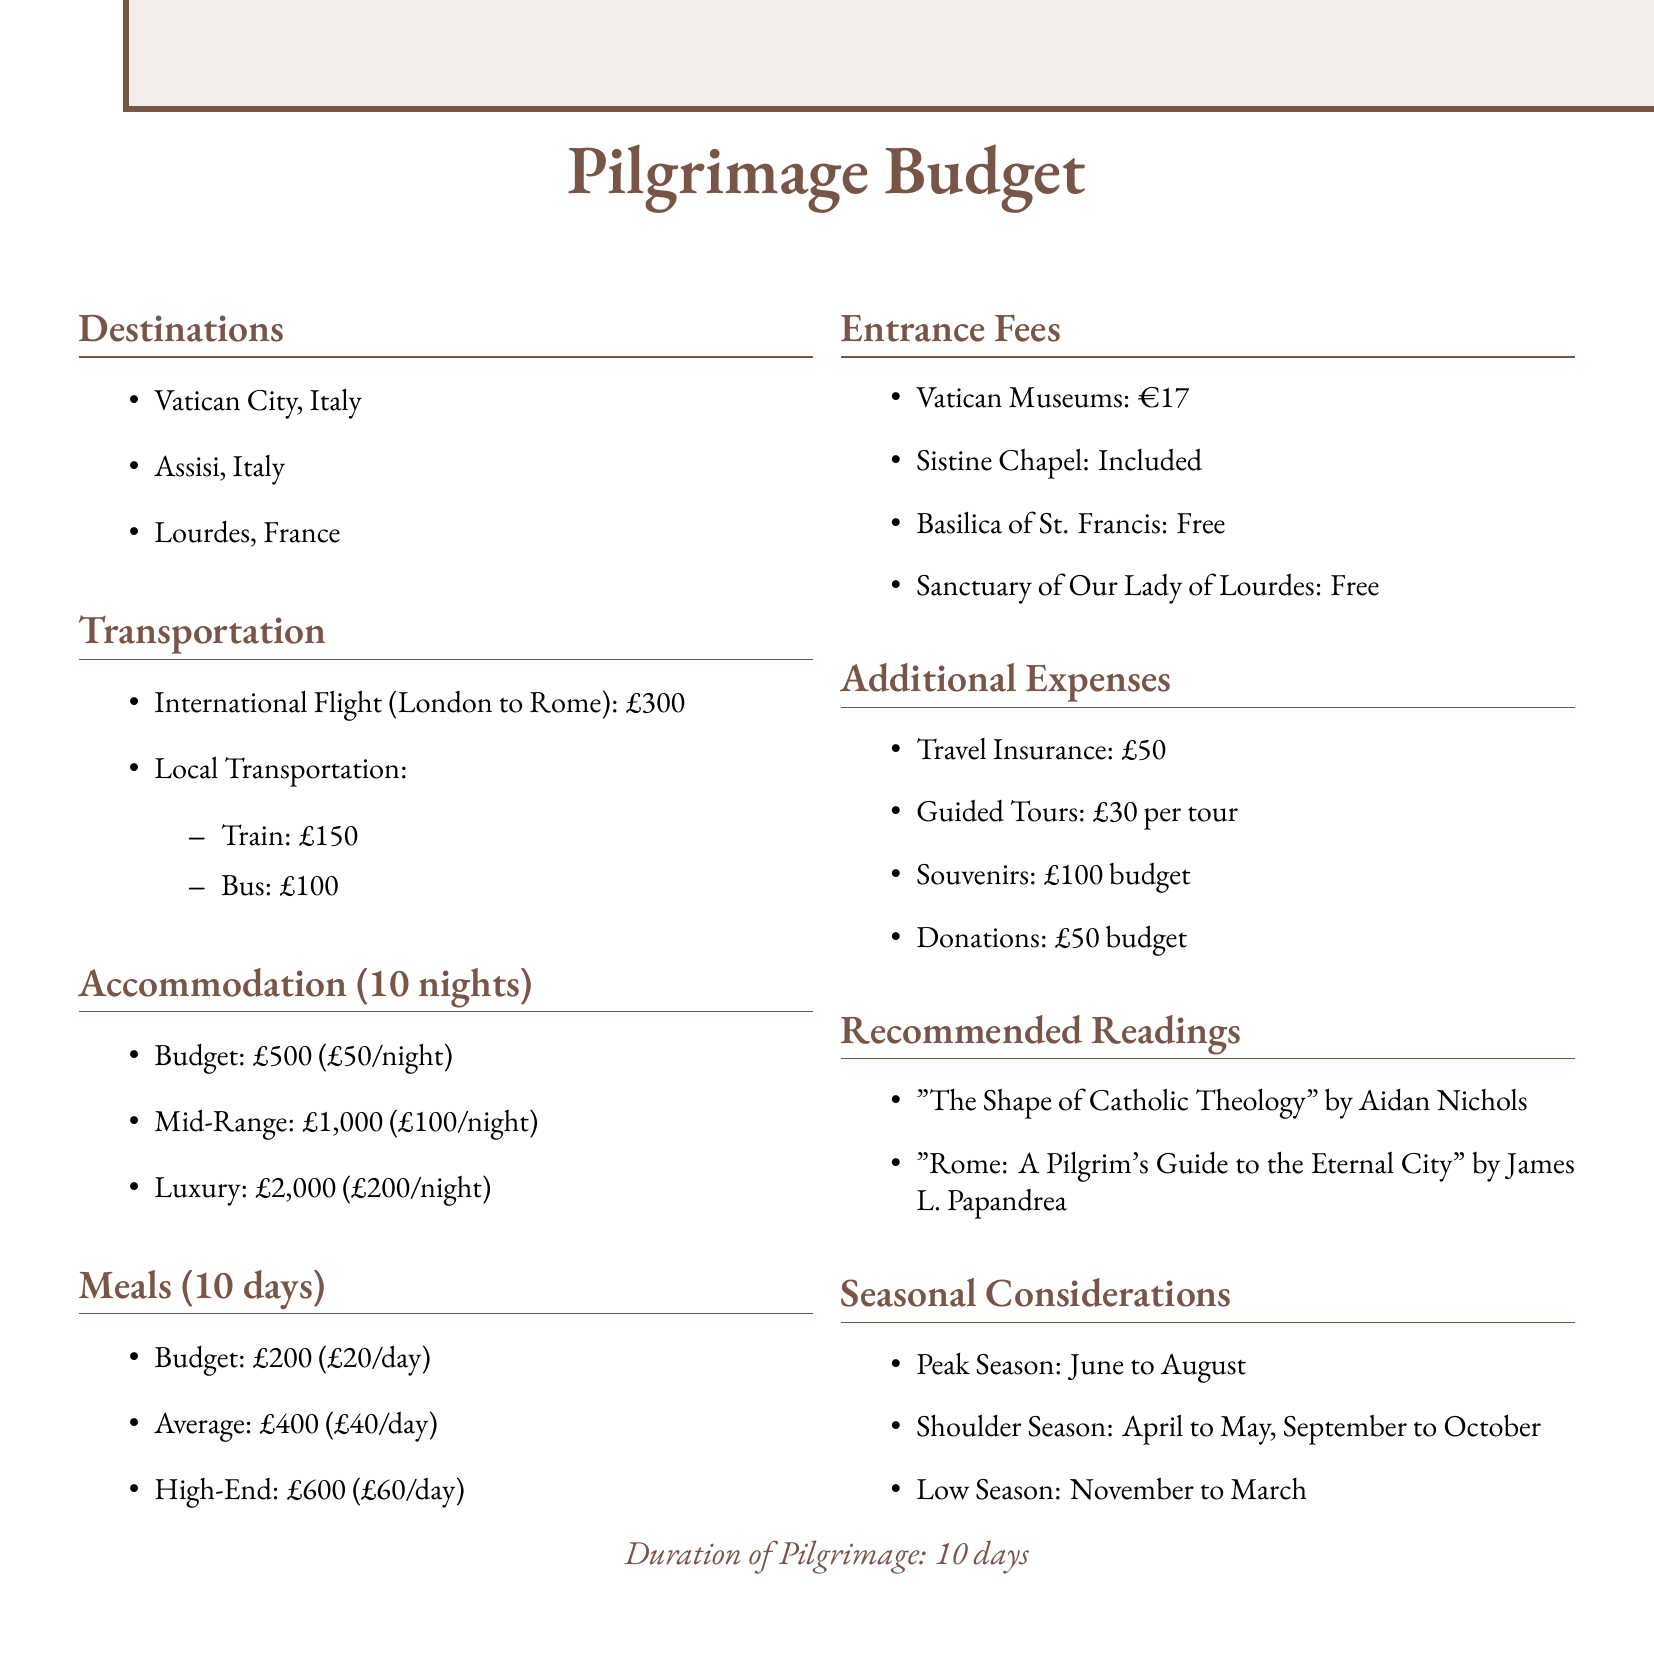What are the pilgrimage destinations? The destinations are listed in the document as significant sites in Catholic history.
Answer: Vatican City, Assisi, Lourdes What is the cost of the international flight? The document specifies the cost of the flight from London to Rome as part of the transportation section.
Answer: £300 What is the budget for meals? The document outlines different meal budget options for the pilgrimage duration.
Answer: £200 How many nights is the accommodation budget calculated for? The accommodation section mentions how many nights the budget covers.
Answer: 10 nights What is the cost for the Vatican Museums' entrance fee? The entrance fee for the Vatican Museums is explicitly stated in the document.
Answer: €17 What is the total budget for guided tours if two tours are taken? This requires calculating the cost based on the number of tours and the price per tour mentioned.
Answer: £60 What is the recommended reading by Aidan Nichols? The document lists recommended readings, including works by Aidan Nichols.
Answer: "The Shape of Catholic Theology" What is the duration of the pilgrimage? The duration of the pilgrimage is explicitly mentioned in the document.
Answer: 10 days What is the local transportation budget? The document includes the total costs associated with local transportation options.
Answer: £250 